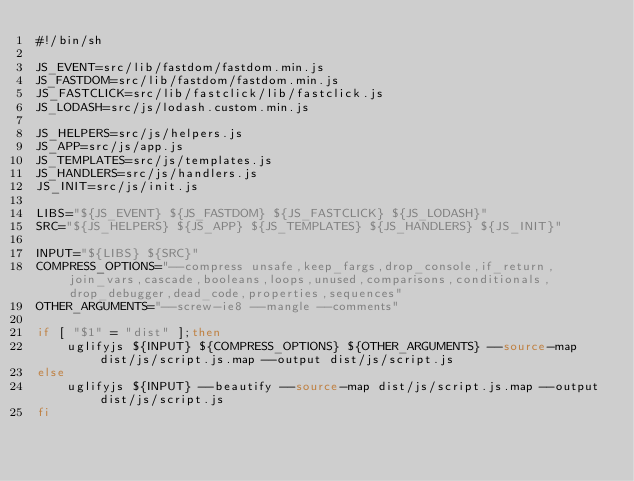<code> <loc_0><loc_0><loc_500><loc_500><_Bash_>#!/bin/sh

JS_EVENT=src/lib/fastdom/fastdom.min.js
JS_FASTDOM=src/lib/fastdom/fastdom.min.js
JS_FASTCLICK=src/lib/fastclick/lib/fastclick.js
JS_LODASH=src/js/lodash.custom.min.js

JS_HELPERS=src/js/helpers.js
JS_APP=src/js/app.js
JS_TEMPLATES=src/js/templates.js
JS_HANDLERS=src/js/handlers.js
JS_INIT=src/js/init.js

LIBS="${JS_EVENT} ${JS_FASTDOM} ${JS_FASTCLICK} ${JS_LODASH}"
SRC="${JS_HELPERS} ${JS_APP} ${JS_TEMPLATES} ${JS_HANDLERS} ${JS_INIT}"

INPUT="${LIBS} ${SRC}"
COMPRESS_OPTIONS="--compress unsafe,keep_fargs,drop_console,if_return,join_vars,cascade,booleans,loops,unused,comparisons,conditionals,drop_debugger,dead_code,properties,sequences"
OTHER_ARGUMENTS="--screw-ie8 --mangle --comments"

if [ "$1" = "dist" ];then
    uglifyjs ${INPUT} ${COMPRESS_OPTIONS} ${OTHER_ARGUMENTS} --source-map dist/js/script.js.map --output dist/js/script.js
else
    uglifyjs ${INPUT} --beautify --source-map dist/js/script.js.map --output dist/js/script.js
fi
</code> 